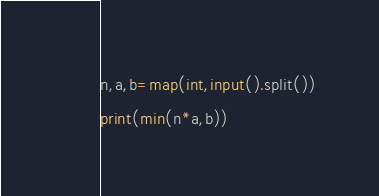Convert code to text. <code><loc_0><loc_0><loc_500><loc_500><_Python_>n,a,b=map(int,input().split())
print(min(n*a,b))</code> 